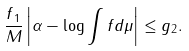Convert formula to latex. <formula><loc_0><loc_0><loc_500><loc_500>\frac { \| f \| _ { 1 } } { M } \left | \alpha - \log \int f d \mu \right | \leq \| g \| _ { 2 } .</formula> 